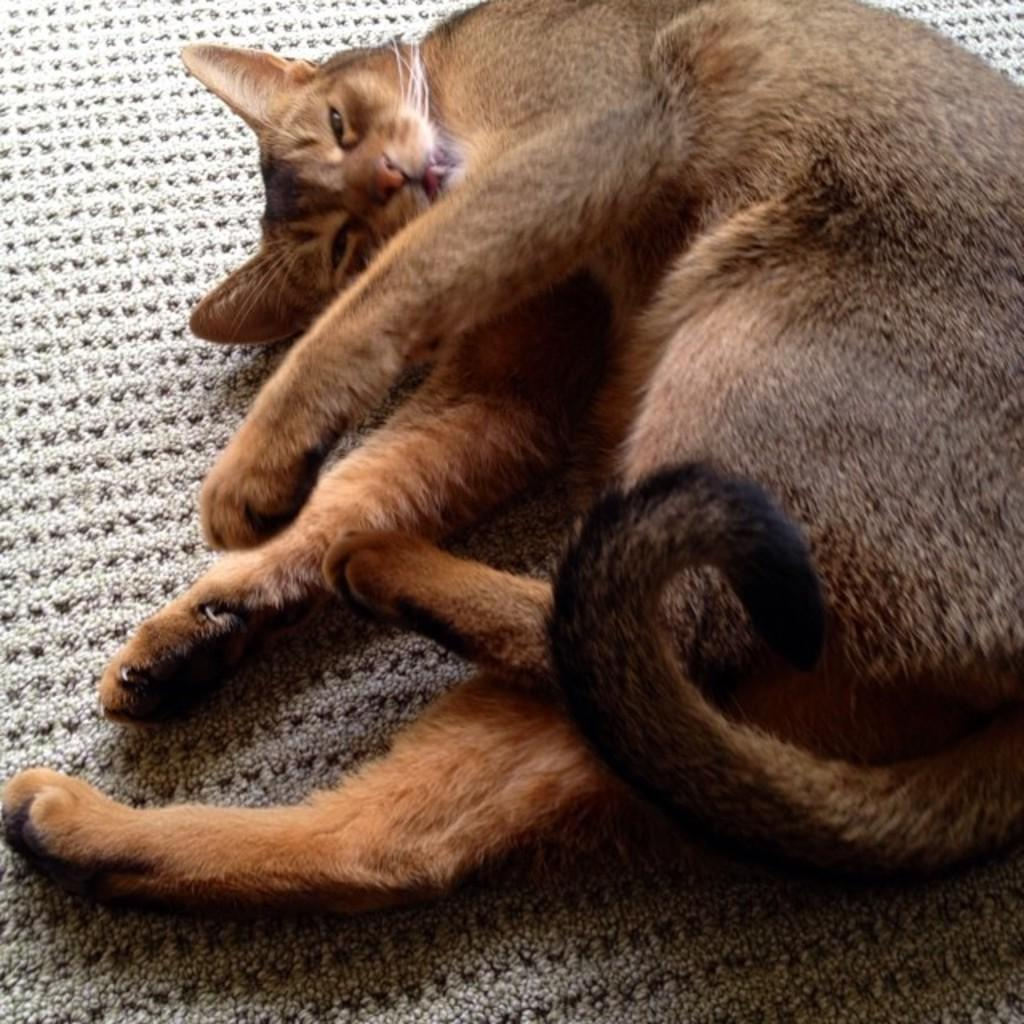What type of animal is in the image? There is a cat in the image. What is the cat doing in the image? The cat is sleeping. Where is the cat located in the image? The cat is on a mat. What type of destruction is the cat causing in the image? There is no destruction caused by the cat in the image; the cat is sleeping on a mat. What type of net is visible in the image? There is no net present in the image. 